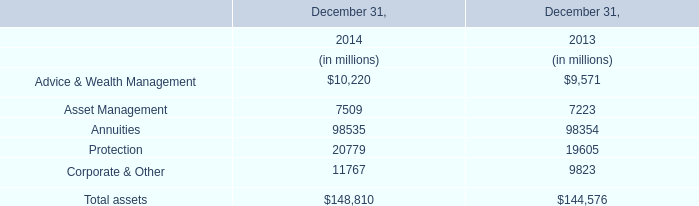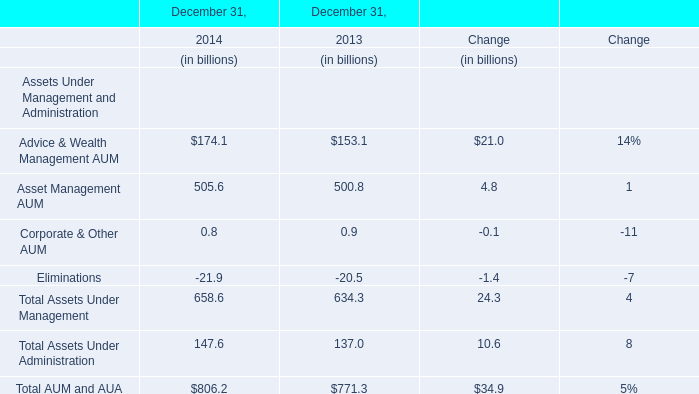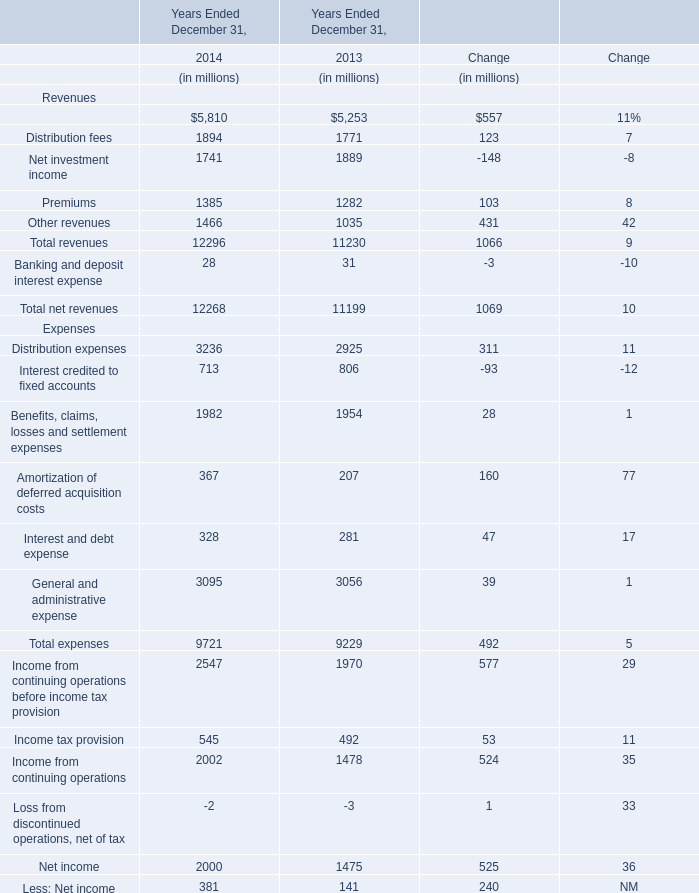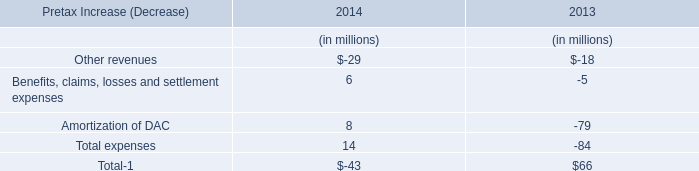What's the total amount of Management and financial advice fees,Distribution fees,Premiums and Other revenues in 2014? (in dollars in millions) 
Computations: (((5810 + 1894) + 1385) + 1466)
Answer: 10555.0. 